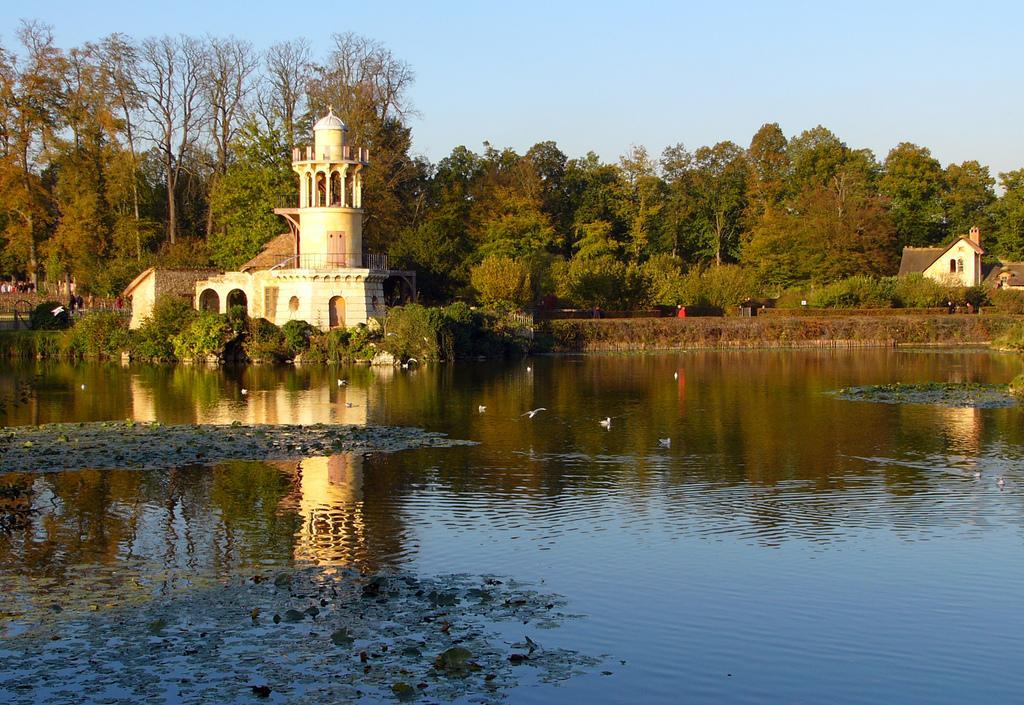Could you give a brief overview of what you see in this image? Here we can see water and birds. Background there are a number of trees, plants and houses. Sky is in blue color.  